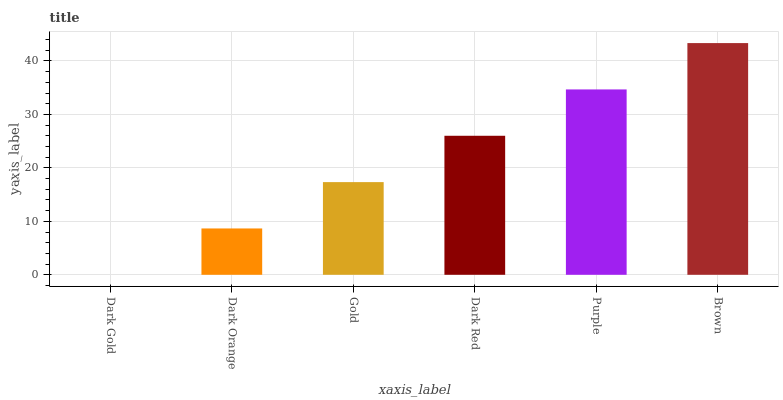Is Dark Gold the minimum?
Answer yes or no. Yes. Is Brown the maximum?
Answer yes or no. Yes. Is Dark Orange the minimum?
Answer yes or no. No. Is Dark Orange the maximum?
Answer yes or no. No. Is Dark Orange greater than Dark Gold?
Answer yes or no. Yes. Is Dark Gold less than Dark Orange?
Answer yes or no. Yes. Is Dark Gold greater than Dark Orange?
Answer yes or no. No. Is Dark Orange less than Dark Gold?
Answer yes or no. No. Is Dark Red the high median?
Answer yes or no. Yes. Is Gold the low median?
Answer yes or no. Yes. Is Purple the high median?
Answer yes or no. No. Is Brown the low median?
Answer yes or no. No. 